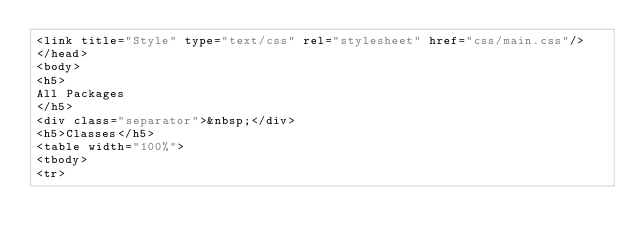<code> <loc_0><loc_0><loc_500><loc_500><_HTML_><link title="Style" type="text/css" rel="stylesheet" href="css/main.css"/>
</head>
<body>
<h5>
All Packages
</h5>
<div class="separator">&nbsp;</div>
<h5>Classes</h5>
<table width="100%">
<tbody>
<tr></code> 